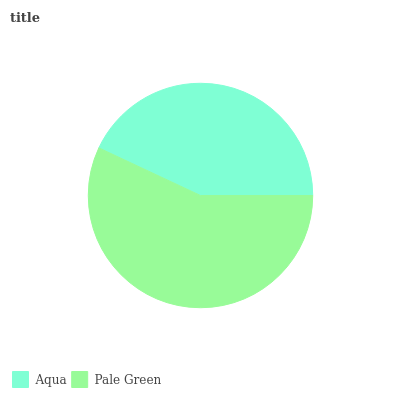Is Aqua the minimum?
Answer yes or no. Yes. Is Pale Green the maximum?
Answer yes or no. Yes. Is Pale Green the minimum?
Answer yes or no. No. Is Pale Green greater than Aqua?
Answer yes or no. Yes. Is Aqua less than Pale Green?
Answer yes or no. Yes. Is Aqua greater than Pale Green?
Answer yes or no. No. Is Pale Green less than Aqua?
Answer yes or no. No. Is Pale Green the high median?
Answer yes or no. Yes. Is Aqua the low median?
Answer yes or no. Yes. Is Aqua the high median?
Answer yes or no. No. Is Pale Green the low median?
Answer yes or no. No. 